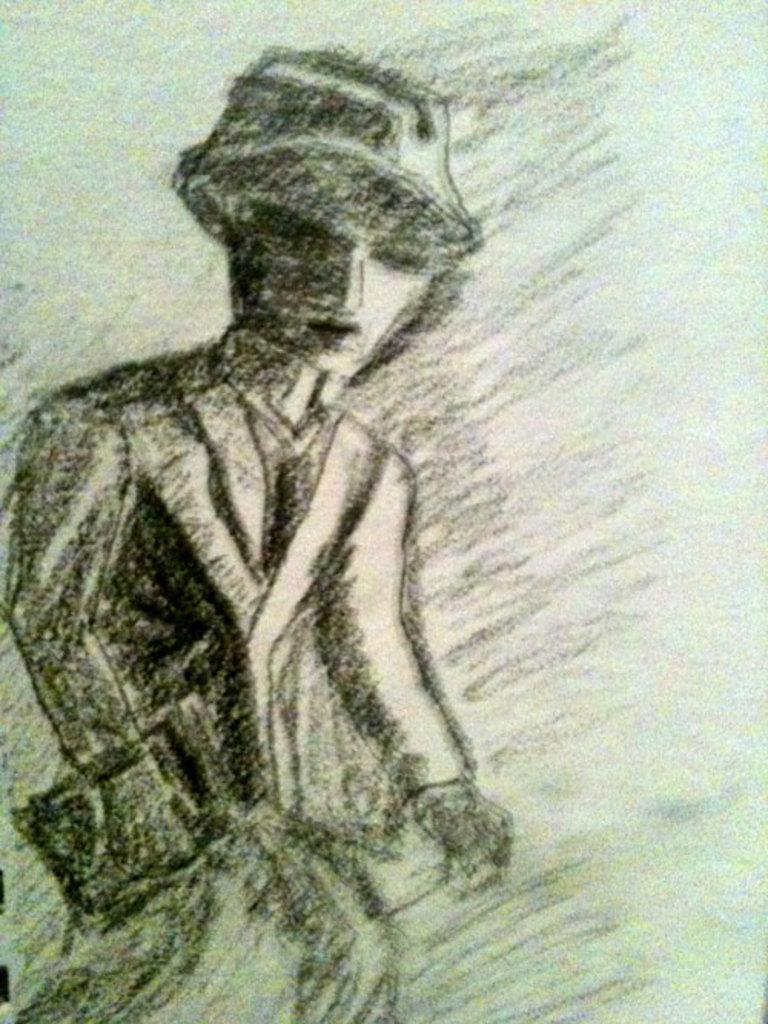What is depicted in the image? There is a sketch of a person in the image. What color is used for the sketch? The sketch is in black color. What is the color of the background in the image? The background of the image is white. What type of bushes can be seen surrounding the queen in the image? There is no queen or bushes present in the image; it features a sketch of a person in black color with a white background. 